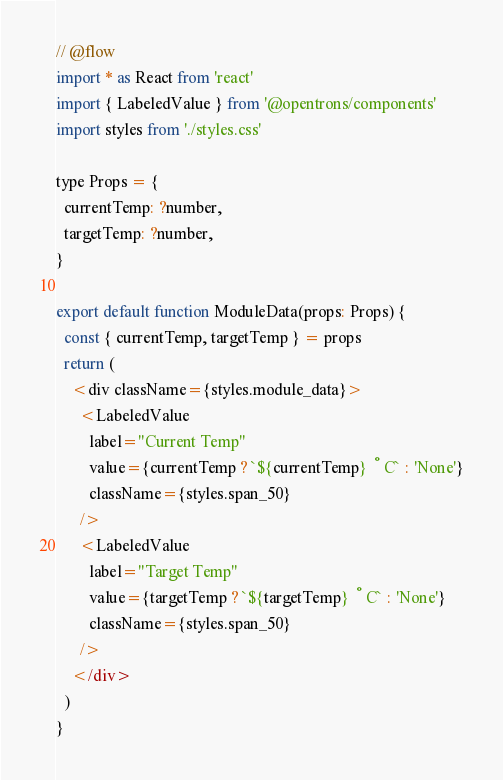Convert code to text. <code><loc_0><loc_0><loc_500><loc_500><_JavaScript_>// @flow
import * as React from 'react'
import { LabeledValue } from '@opentrons/components'
import styles from './styles.css'

type Props = {
  currentTemp: ?number,
  targetTemp: ?number,
}

export default function ModuleData(props: Props) {
  const { currentTemp, targetTemp } = props
  return (
    <div className={styles.module_data}>
      <LabeledValue
        label="Current Temp"
        value={currentTemp ? `${currentTemp} °C` : 'None'}
        className={styles.span_50}
      />
      <LabeledValue
        label="Target Temp"
        value={targetTemp ? `${targetTemp} °C` : 'None'}
        className={styles.span_50}
      />
    </div>
  )
}
</code> 